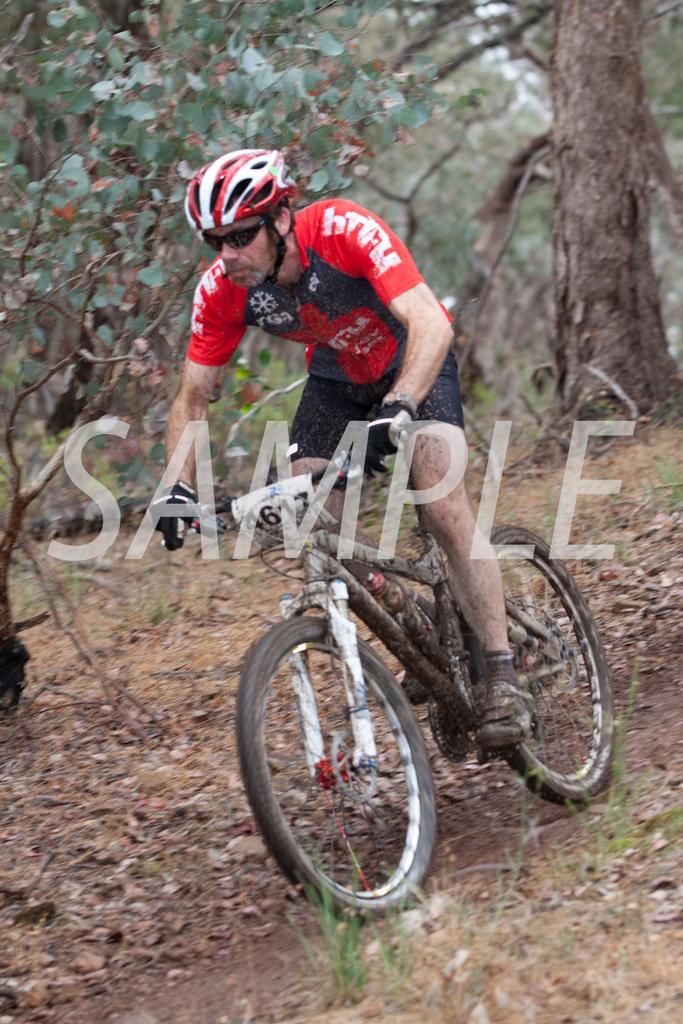Who is in the image? There is a man in the image. What is the man doing in the image? The man is sitting on a bicycle. What can be seen in the background of the image? There are trees visible in the background of the image. What is the man wearing for safety? The man is wearing a helmet. What type of sweater is the man wearing in the alley with the crook? There is no sweater, alley, or crook mentioned in the image. The man is wearing a helmet while sitting on a bicycle with trees in the background. 